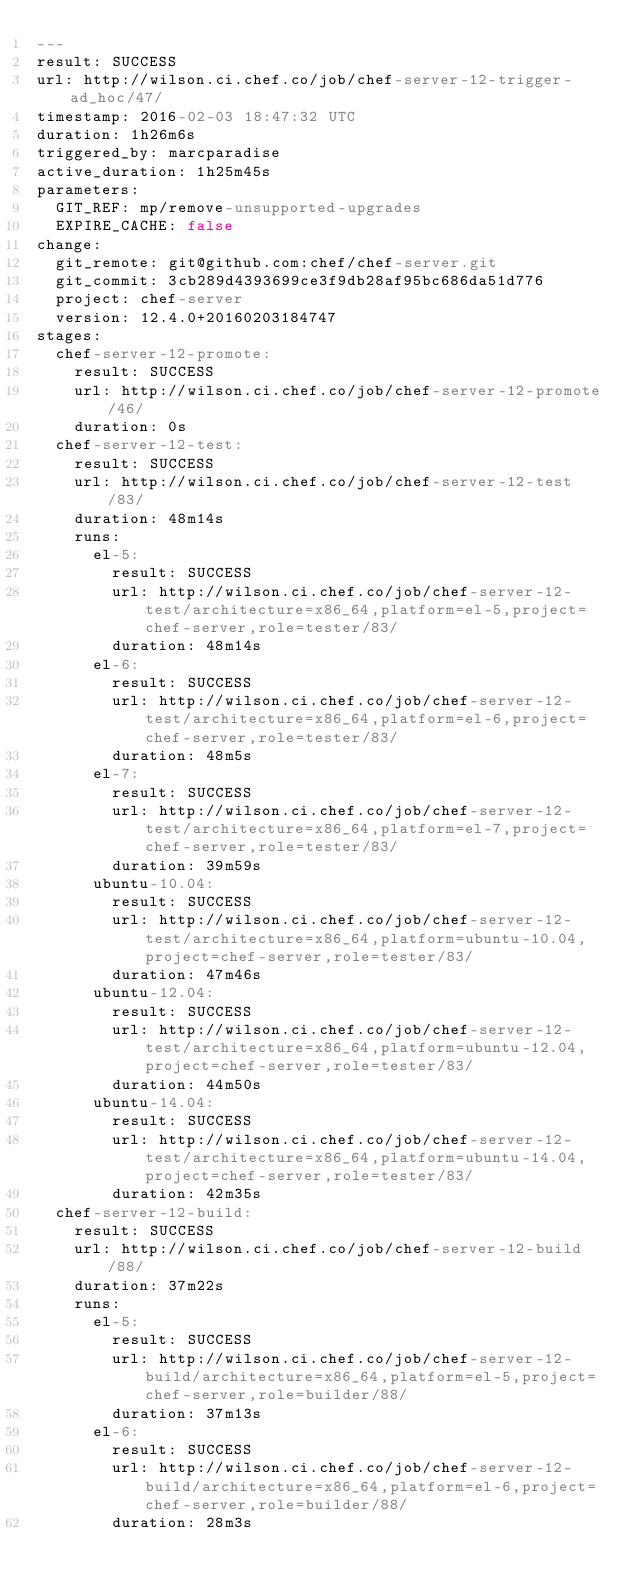Convert code to text. <code><loc_0><loc_0><loc_500><loc_500><_YAML_>---
result: SUCCESS
url: http://wilson.ci.chef.co/job/chef-server-12-trigger-ad_hoc/47/
timestamp: 2016-02-03 18:47:32 UTC
duration: 1h26m6s
triggered_by: marcparadise
active_duration: 1h25m45s
parameters:
  GIT_REF: mp/remove-unsupported-upgrades
  EXPIRE_CACHE: false
change:
  git_remote: git@github.com:chef/chef-server.git
  git_commit: 3cb289d4393699ce3f9db28af95bc686da51d776
  project: chef-server
  version: 12.4.0+20160203184747
stages:
  chef-server-12-promote:
    result: SUCCESS
    url: http://wilson.ci.chef.co/job/chef-server-12-promote/46/
    duration: 0s
  chef-server-12-test:
    result: SUCCESS
    url: http://wilson.ci.chef.co/job/chef-server-12-test/83/
    duration: 48m14s
    runs:
      el-5:
        result: SUCCESS
        url: http://wilson.ci.chef.co/job/chef-server-12-test/architecture=x86_64,platform=el-5,project=chef-server,role=tester/83/
        duration: 48m14s
      el-6:
        result: SUCCESS
        url: http://wilson.ci.chef.co/job/chef-server-12-test/architecture=x86_64,platform=el-6,project=chef-server,role=tester/83/
        duration: 48m5s
      el-7:
        result: SUCCESS
        url: http://wilson.ci.chef.co/job/chef-server-12-test/architecture=x86_64,platform=el-7,project=chef-server,role=tester/83/
        duration: 39m59s
      ubuntu-10.04:
        result: SUCCESS
        url: http://wilson.ci.chef.co/job/chef-server-12-test/architecture=x86_64,platform=ubuntu-10.04,project=chef-server,role=tester/83/
        duration: 47m46s
      ubuntu-12.04:
        result: SUCCESS
        url: http://wilson.ci.chef.co/job/chef-server-12-test/architecture=x86_64,platform=ubuntu-12.04,project=chef-server,role=tester/83/
        duration: 44m50s
      ubuntu-14.04:
        result: SUCCESS
        url: http://wilson.ci.chef.co/job/chef-server-12-test/architecture=x86_64,platform=ubuntu-14.04,project=chef-server,role=tester/83/
        duration: 42m35s
  chef-server-12-build:
    result: SUCCESS
    url: http://wilson.ci.chef.co/job/chef-server-12-build/88/
    duration: 37m22s
    runs:
      el-5:
        result: SUCCESS
        url: http://wilson.ci.chef.co/job/chef-server-12-build/architecture=x86_64,platform=el-5,project=chef-server,role=builder/88/
        duration: 37m13s
      el-6:
        result: SUCCESS
        url: http://wilson.ci.chef.co/job/chef-server-12-build/architecture=x86_64,platform=el-6,project=chef-server,role=builder/88/
        duration: 28m3s</code> 